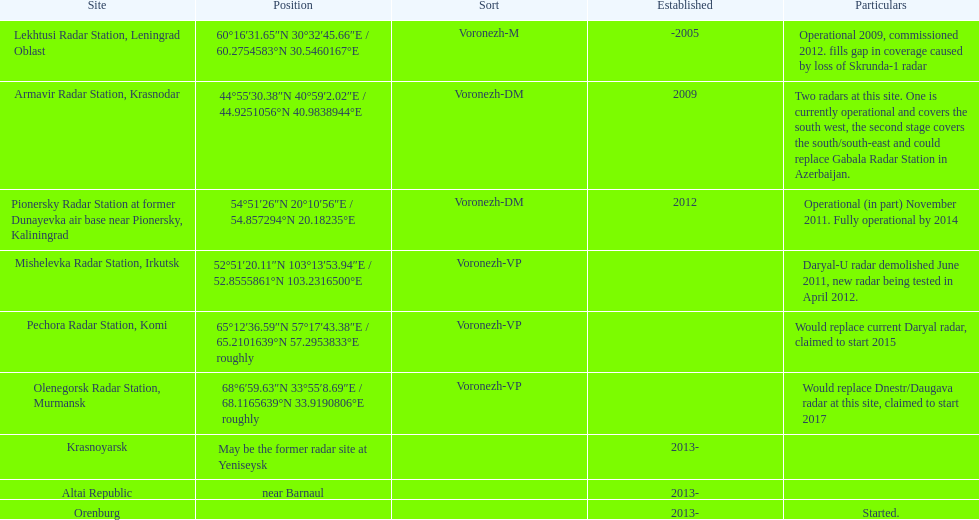How long did it take the pionersky radar station to go from partially operational to fully operational? 3 years. 